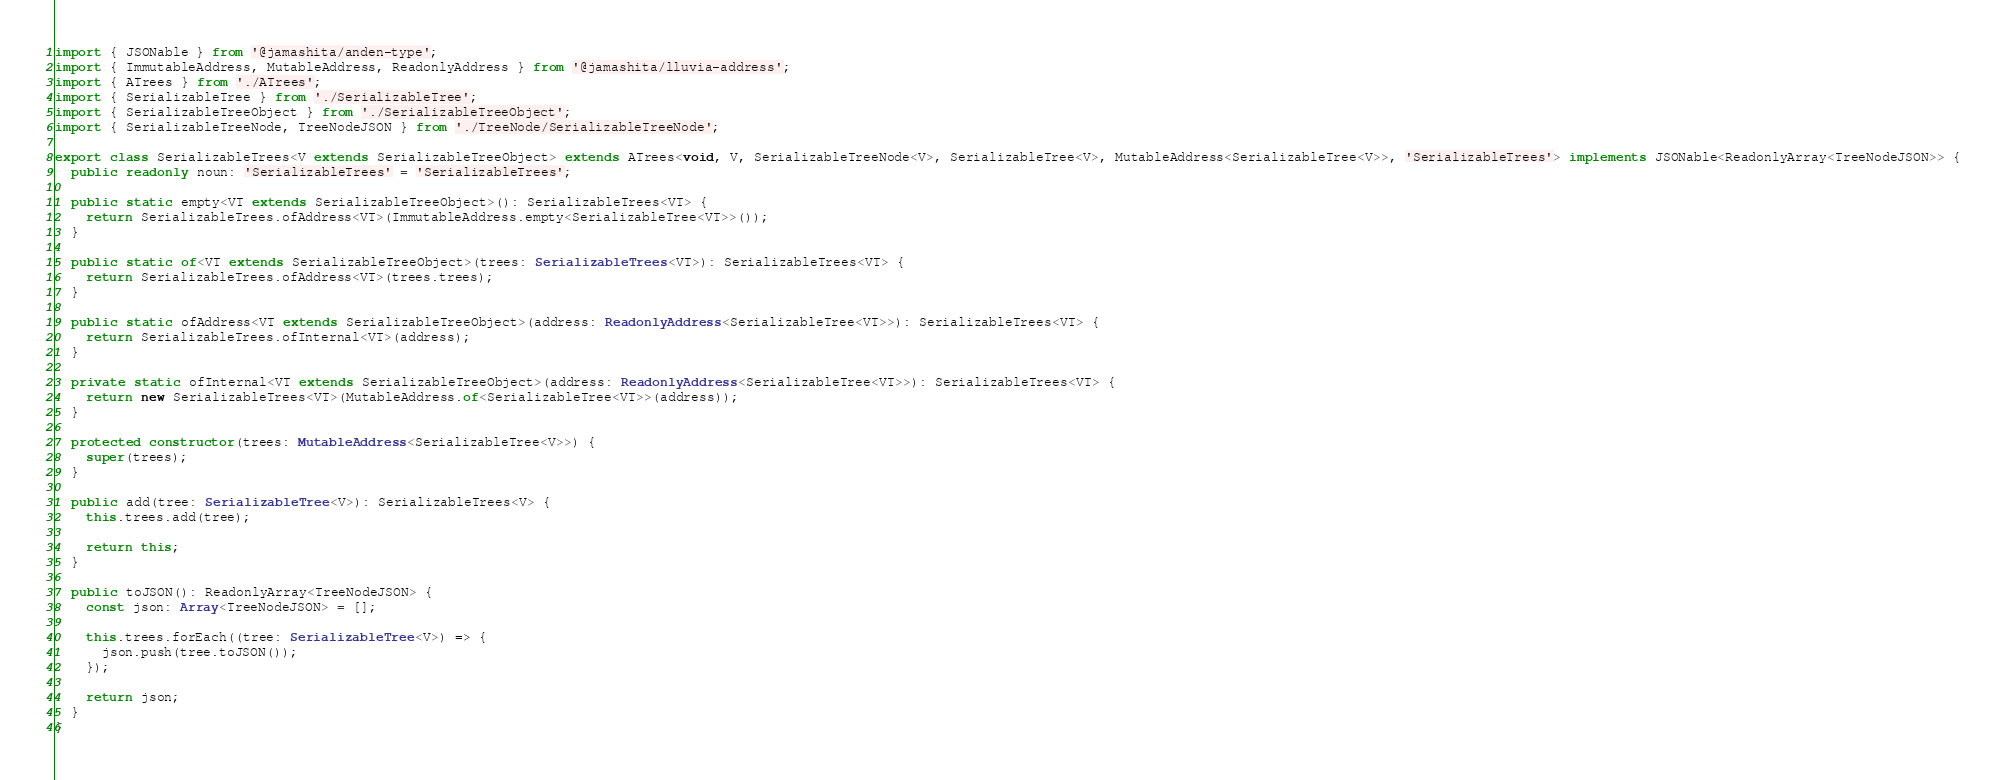Convert code to text. <code><loc_0><loc_0><loc_500><loc_500><_TypeScript_>import { JSONable } from '@jamashita/anden-type';
import { ImmutableAddress, MutableAddress, ReadonlyAddress } from '@jamashita/lluvia-address';
import { ATrees } from './ATrees';
import { SerializableTree } from './SerializableTree';
import { SerializableTreeObject } from './SerializableTreeObject';
import { SerializableTreeNode, TreeNodeJSON } from './TreeNode/SerializableTreeNode';

export class SerializableTrees<V extends SerializableTreeObject> extends ATrees<void, V, SerializableTreeNode<V>, SerializableTree<V>, MutableAddress<SerializableTree<V>>, 'SerializableTrees'> implements JSONable<ReadonlyArray<TreeNodeJSON>> {
  public readonly noun: 'SerializableTrees' = 'SerializableTrees';

  public static empty<VT extends SerializableTreeObject>(): SerializableTrees<VT> {
    return SerializableTrees.ofAddress<VT>(ImmutableAddress.empty<SerializableTree<VT>>());
  }

  public static of<VT extends SerializableTreeObject>(trees: SerializableTrees<VT>): SerializableTrees<VT> {
    return SerializableTrees.ofAddress<VT>(trees.trees);
  }

  public static ofAddress<VT extends SerializableTreeObject>(address: ReadonlyAddress<SerializableTree<VT>>): SerializableTrees<VT> {
    return SerializableTrees.ofInternal<VT>(address);
  }

  private static ofInternal<VT extends SerializableTreeObject>(address: ReadonlyAddress<SerializableTree<VT>>): SerializableTrees<VT> {
    return new SerializableTrees<VT>(MutableAddress.of<SerializableTree<VT>>(address));
  }

  protected constructor(trees: MutableAddress<SerializableTree<V>>) {
    super(trees);
  }

  public add(tree: SerializableTree<V>): SerializableTrees<V> {
    this.trees.add(tree);

    return this;
  }

  public toJSON(): ReadonlyArray<TreeNodeJSON> {
    const json: Array<TreeNodeJSON> = [];

    this.trees.forEach((tree: SerializableTree<V>) => {
      json.push(tree.toJSON());
    });

    return json;
  }
}
</code> 